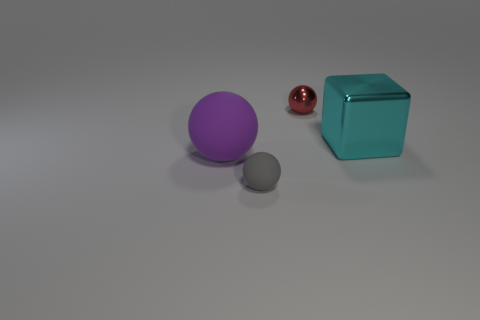Subtract all small spheres. How many spheres are left? 1 Add 2 small red metallic cylinders. How many objects exist? 6 Subtract 1 balls. How many balls are left? 2 Subtract all cubes. How many objects are left? 3 Subtract all small metallic objects. Subtract all metal things. How many objects are left? 1 Add 3 large shiny things. How many large shiny things are left? 4 Add 4 large purple shiny cylinders. How many large purple shiny cylinders exist? 4 Subtract 0 gray blocks. How many objects are left? 4 